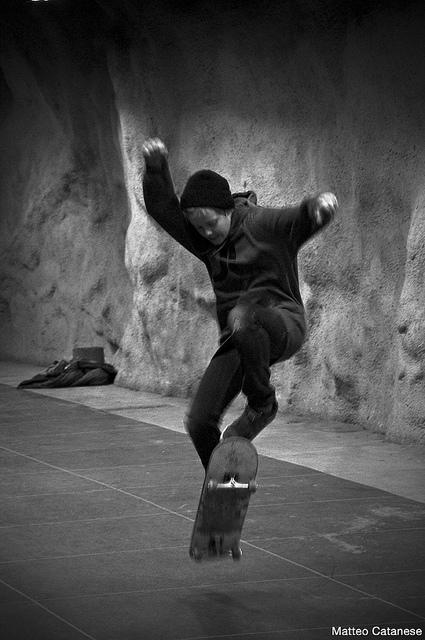What is the boy wearing on his head?

Choices:
A) helmet
B) fedora
C) beanie
D) baseball cap beanie 